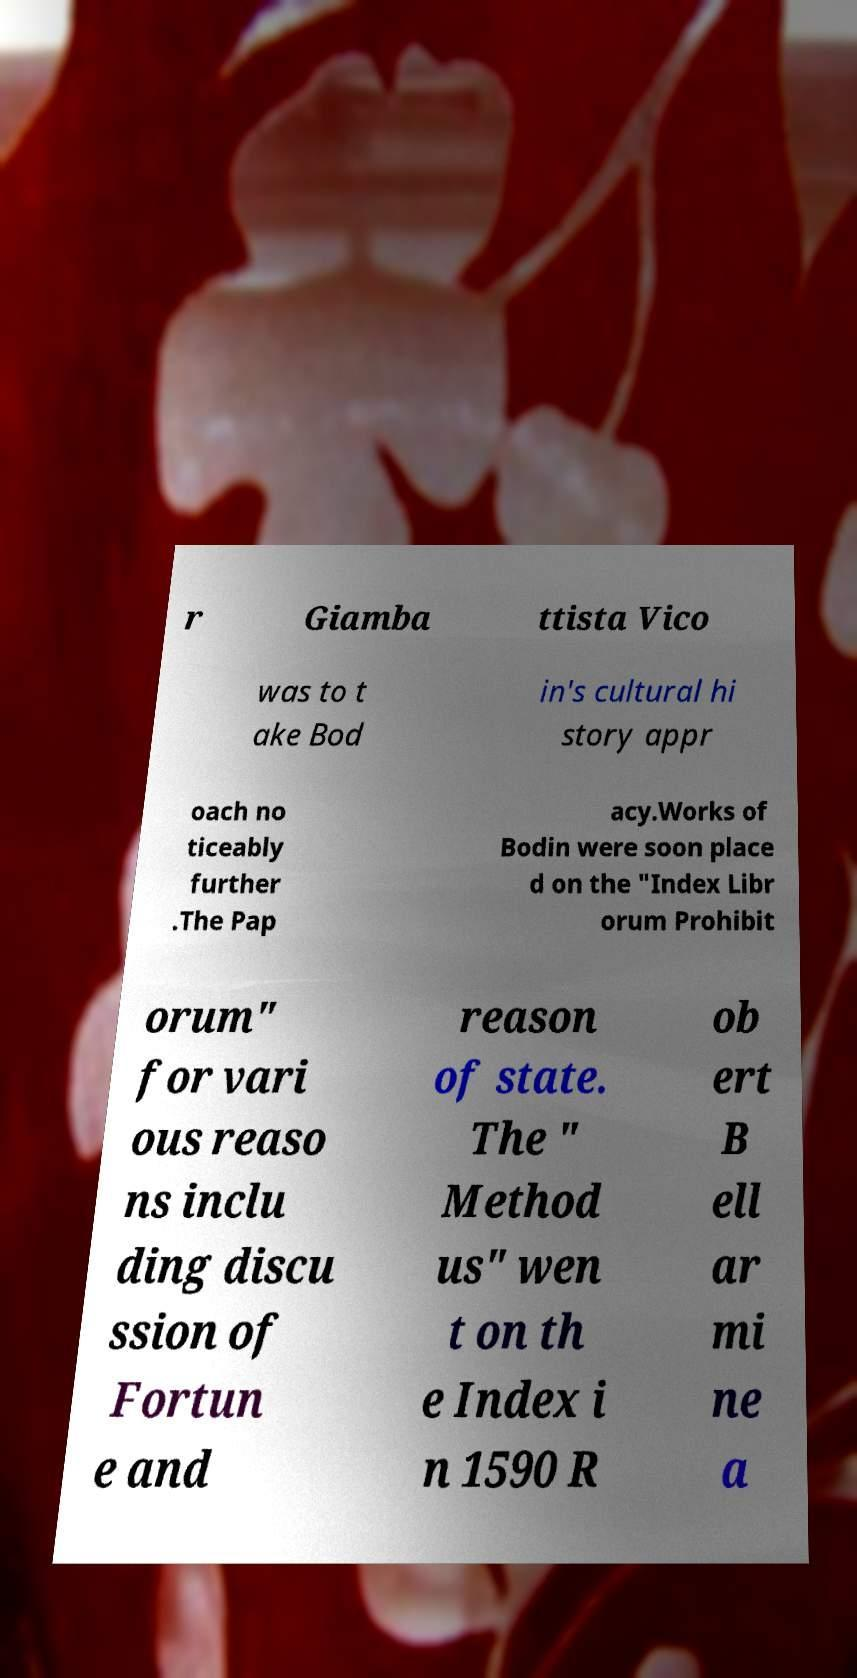Please identify and transcribe the text found in this image. r Giamba ttista Vico was to t ake Bod in's cultural hi story appr oach no ticeably further .The Pap acy.Works of Bodin were soon place d on the "Index Libr orum Prohibit orum" for vari ous reaso ns inclu ding discu ssion of Fortun e and reason of state. The " Method us" wen t on th e Index i n 1590 R ob ert B ell ar mi ne a 